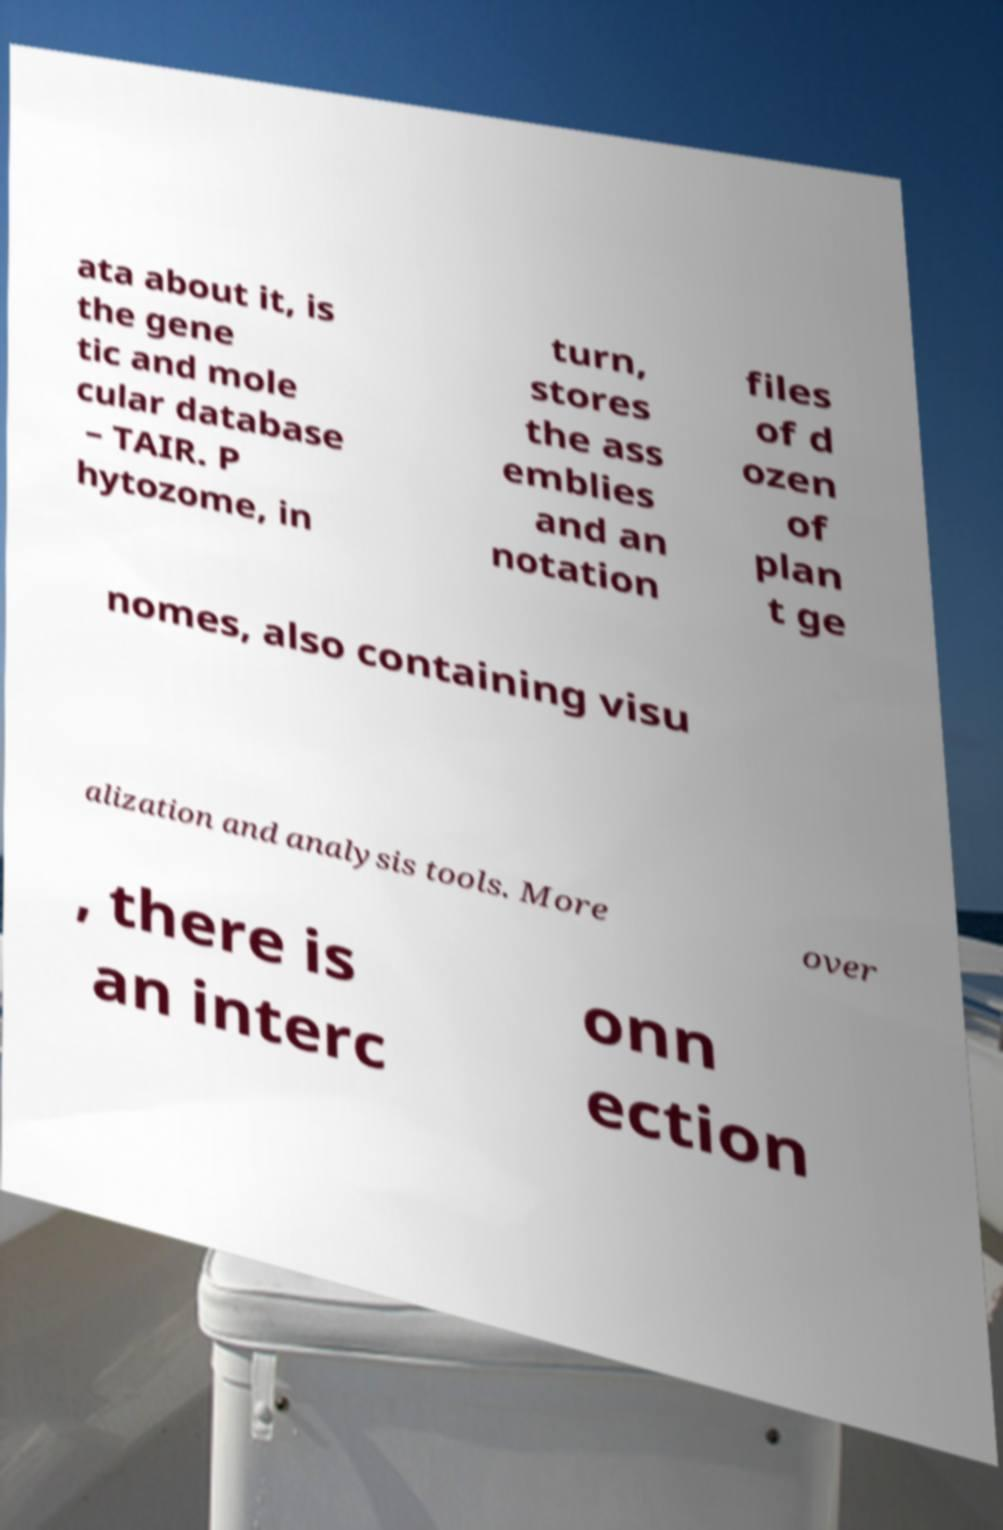Please read and relay the text visible in this image. What does it say? ata about it, is the gene tic and mole cular database – TAIR. P hytozome, in turn, stores the ass emblies and an notation files of d ozen of plan t ge nomes, also containing visu alization and analysis tools. More over , there is an interc onn ection 